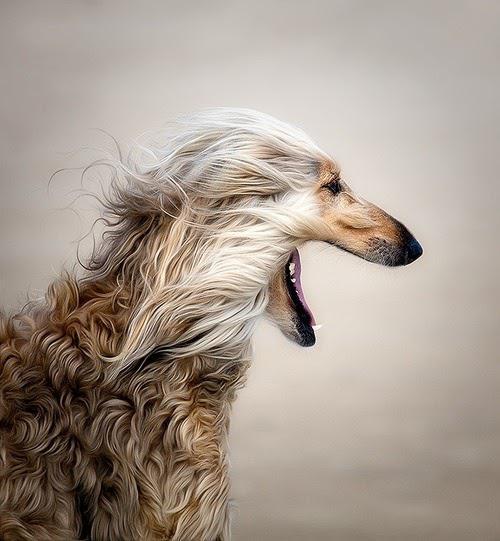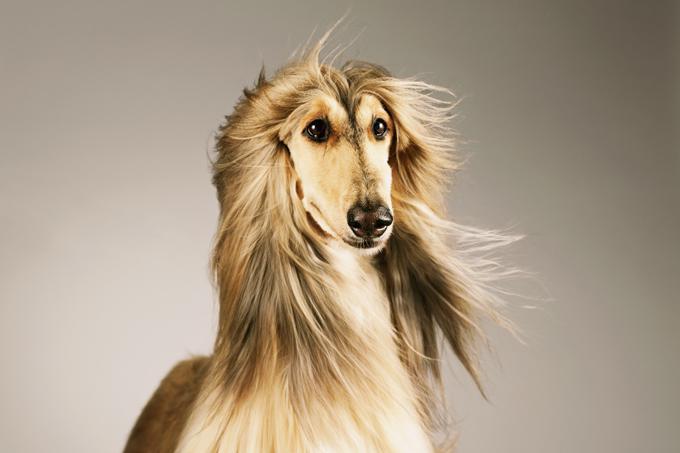The first image is the image on the left, the second image is the image on the right. Given the left and right images, does the statement "Four dog feet are visible in the image on the left." hold true? Answer yes or no. No. 